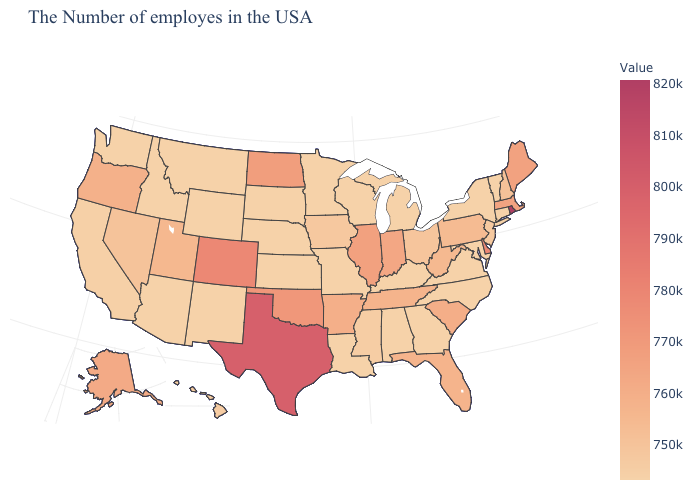Which states hav the highest value in the MidWest?
Quick response, please. North Dakota. Does Nebraska have a lower value than Oklahoma?
Be succinct. Yes. Which states have the lowest value in the MidWest?
Give a very brief answer. Michigan, Wisconsin, Missouri, Minnesota, Kansas, Nebraska, South Dakota. Does the map have missing data?
Give a very brief answer. No. 